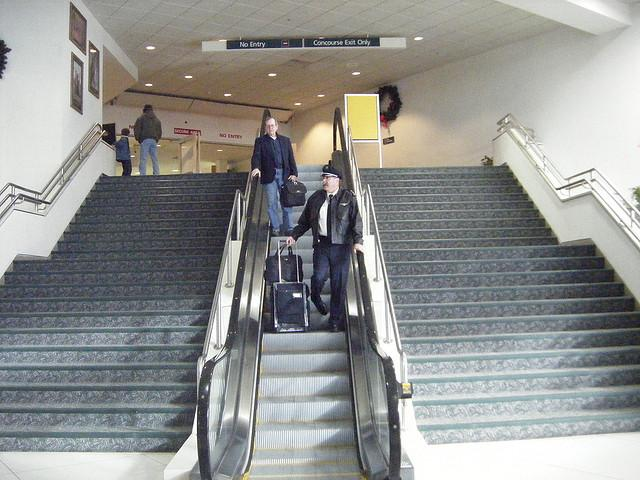Where are the two old men located in? Please explain your reasoning. airport. The men have luggage, the word concourse is seen on a sign and one of the men is dressed like a pilot. 